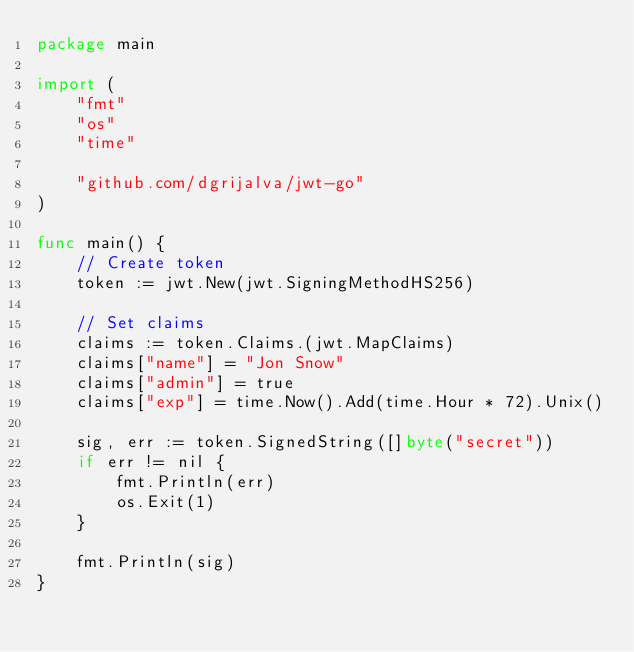Convert code to text. <code><loc_0><loc_0><loc_500><loc_500><_Go_>package main

import (
	"fmt"
	"os"
	"time"

	"github.com/dgrijalva/jwt-go"
)

func main() {
	// Create token
	token := jwt.New(jwt.SigningMethodHS256)

	// Set claims
	claims := token.Claims.(jwt.MapClaims)
	claims["name"] = "Jon Snow"
	claims["admin"] = true
	claims["exp"] = time.Now().Add(time.Hour * 72).Unix()

	sig, err := token.SignedString([]byte("secret"))
	if err != nil {
		fmt.Println(err)
		os.Exit(1)
	}

	fmt.Println(sig)
}
</code> 